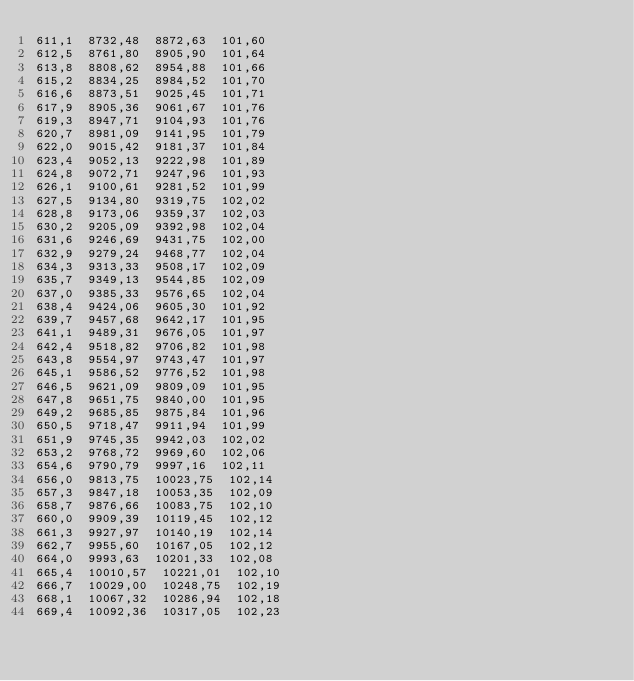Convert code to text. <code><loc_0><loc_0><loc_500><loc_500><_SML_>611,1  8732,48  8872,63  101,60
612,5  8761,80  8905,90  101,64
613,8  8808,62  8954,88  101,66
615,2  8834,25  8984,52  101,70
616,6  8873,51  9025,45  101,71
617,9  8905,36  9061,67  101,76
619,3  8947,71  9104,93  101,76
620,7  8981,09  9141,95  101,79
622,0  9015,42  9181,37  101,84
623,4  9052,13  9222,98  101,89
624,8  9072,71  9247,96  101,93
626,1  9100,61  9281,52  101,99
627,5  9134,80  9319,75  102,02
628,8  9173,06  9359,37  102,03
630,2  9205,09  9392,98  102,04
631,6  9246,69  9431,75  102,00
632,9  9279,24  9468,77  102,04
634,3  9313,33  9508,17  102,09
635,7  9349,13  9544,85  102,09
637,0  9385,33  9576,65  102,04
638,4  9424,06  9605,30  101,92
639,7  9457,68  9642,17  101,95
641,1  9489,31  9676,05  101,97
642,4  9518,82  9706,82  101,98
643,8  9554,97  9743,47  101,97
645,1  9586,52  9776,52  101,98
646,5  9621,09  9809,09  101,95
647,8  9651,75  9840,00  101,95
649,2  9685,85  9875,84  101,96
650,5  9718,47  9911,94  101,99
651,9  9745,35  9942,03  102,02
653,2  9768,72  9969,60  102,06
654,6  9790,79  9997,16  102,11
656,0  9813,75  10023,75  102,14
657,3  9847,18  10053,35  102,09
658,7  9876,66  10083,75  102,10
660,0  9909,39  10119,45  102,12
661,3  9927,97  10140,19  102,14
662,7  9955,60  10167,05  102,12
664,0  9993,63  10201,33  102,08
665,4  10010,57  10221,01  102,10
666,7  10029,00  10248,75  102,19
668,1  10067,32  10286,94  102,18
669,4  10092,36  10317,05  102,23</code> 